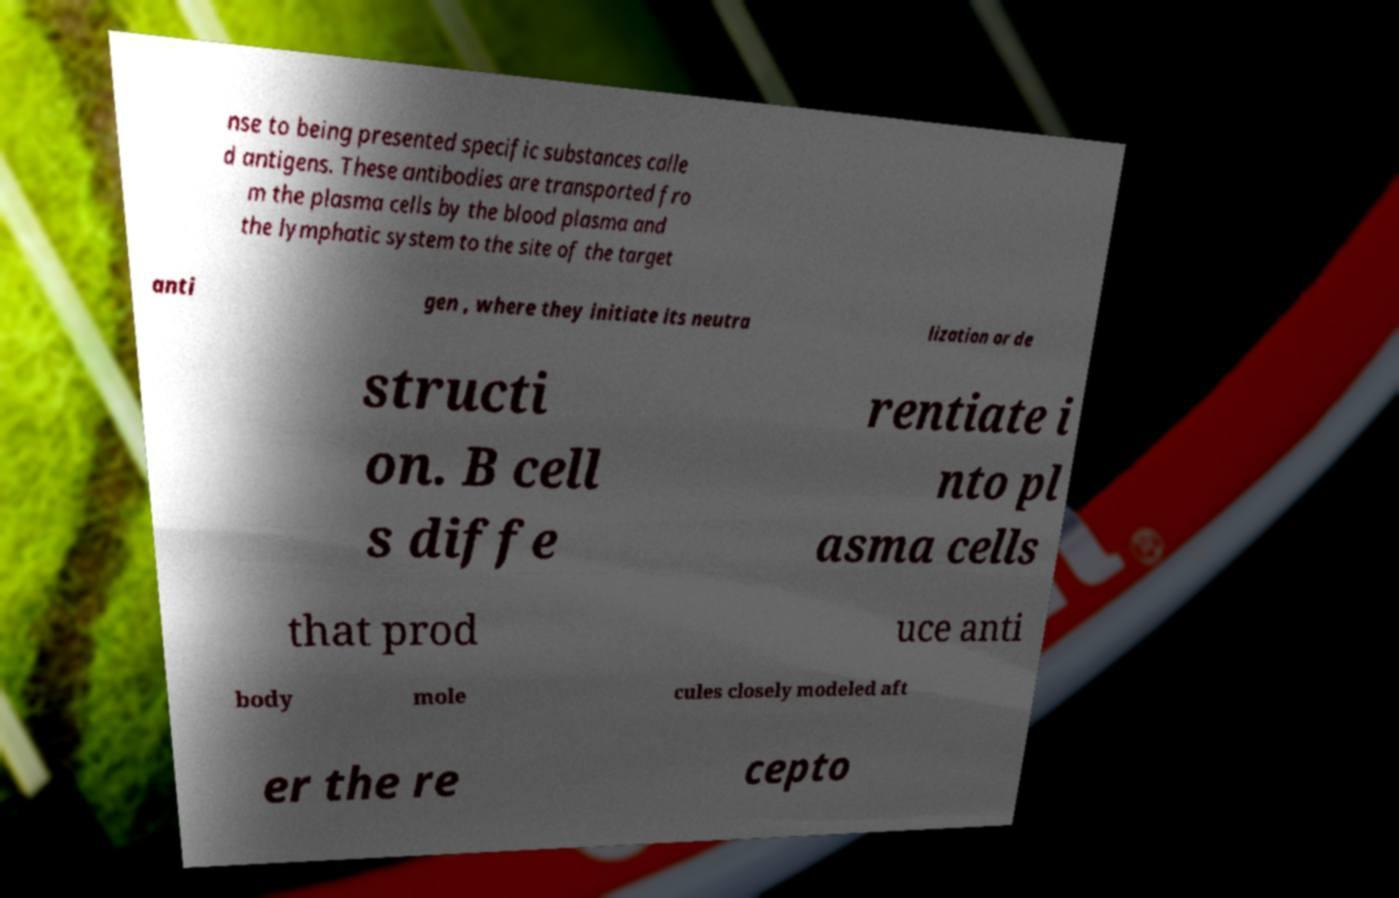Please identify and transcribe the text found in this image. nse to being presented specific substances calle d antigens. These antibodies are transported fro m the plasma cells by the blood plasma and the lymphatic system to the site of the target anti gen , where they initiate its neutra lization or de structi on. B cell s diffe rentiate i nto pl asma cells that prod uce anti body mole cules closely modeled aft er the re cepto 